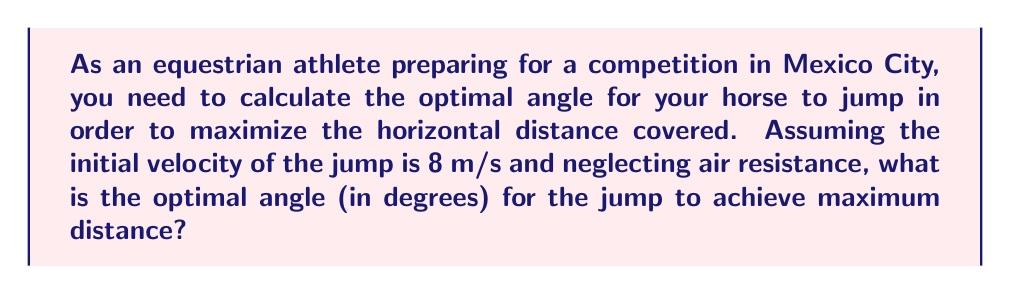Teach me how to tackle this problem. To solve this problem, we'll follow these steps:

1) The optimal angle for projectile motion to achieve maximum distance is always 45° in the absence of air resistance. This is because at 45°, we have an equal balance between the horizontal and vertical components of velocity.

2) However, we need to prove this mathematically:

3) The horizontal distance (d) covered by a projectile is given by the equation:

   $$d = \frac{v_0^2 \sin(2\theta)}{g}$$

   Where:
   $v_0$ is the initial velocity
   $\theta$ is the angle of projection
   $g$ is the acceleration due to gravity (9.8 m/s²)

4) To find the maximum distance, we need to differentiate d with respect to θ and set it to zero:

   $$\frac{d}{d\theta}(\frac{v_0^2 \sin(2\theta)}{g}) = \frac{v_0^2}{g} \cdot 2\cos(2\theta) = 0$$

5) This equation is satisfied when $\cos(2\theta) = 0$, which occurs when $2\theta = 90°$ or $\theta = 45°$

6) To confirm this is a maximum (not a minimum), we can check the second derivative is negative at this point, which it is.

7) Therefore, the optimal angle for the horse jump to maximize distance is 45°.

8) Note that this result is independent of the initial velocity and the acceleration due to gravity, making it universally applicable in ideal conditions.
Answer: 45° 